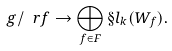Convert formula to latex. <formula><loc_0><loc_0><loc_500><loc_500>\ g / \ r f \to \bigoplus _ { f \in F } \S l _ { k } ( W _ { f } ) .</formula> 